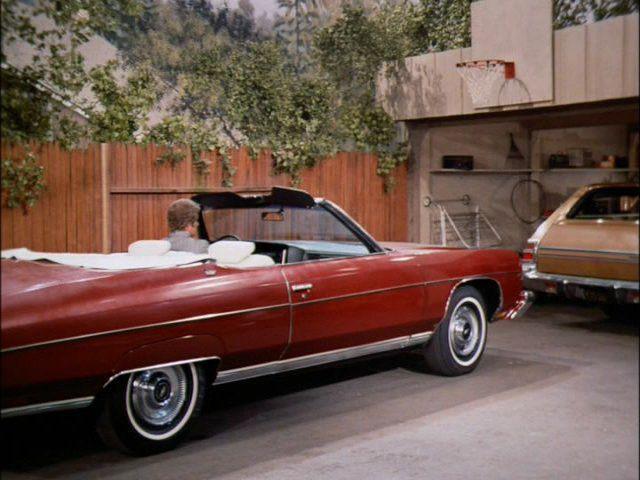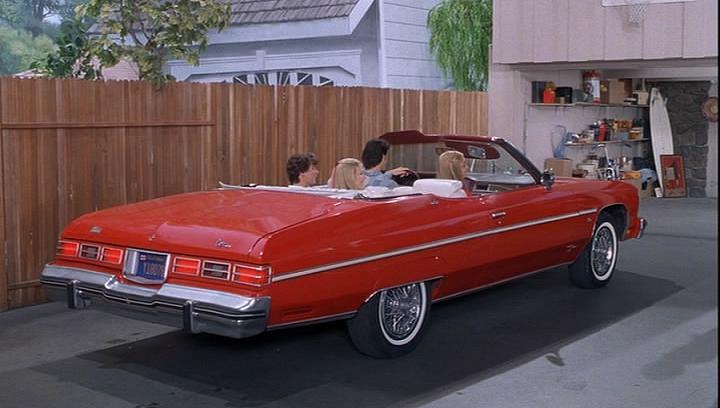The first image is the image on the left, the second image is the image on the right. For the images displayed, is the sentence "The red car on the right is sitting in the driveway." factually correct? Answer yes or no. Yes. The first image is the image on the left, the second image is the image on the right. Examine the images to the left and right. Is the description "Two convertibles with tops completely down are different colors and facing different directions." accurate? Answer yes or no. No. 